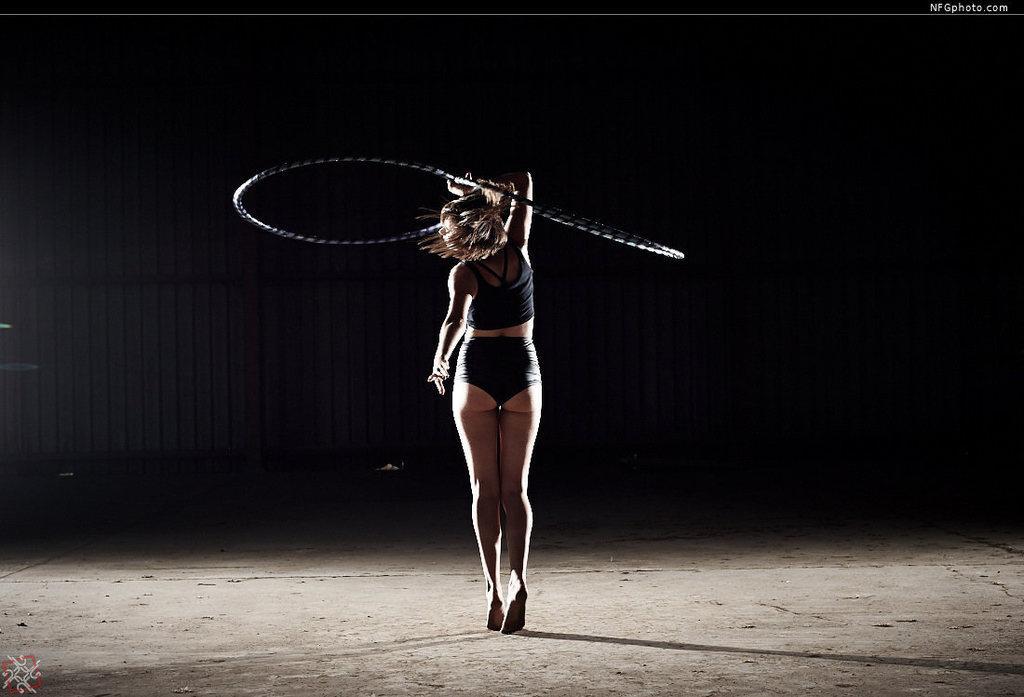Please provide a concise description of this image. In the picture I can see a woman wearing black color dress is holding a rope and standing on the ground. The background of the image is dark. Here we can see the watermark at the bottom left side of the image and at the top right side of the image. 